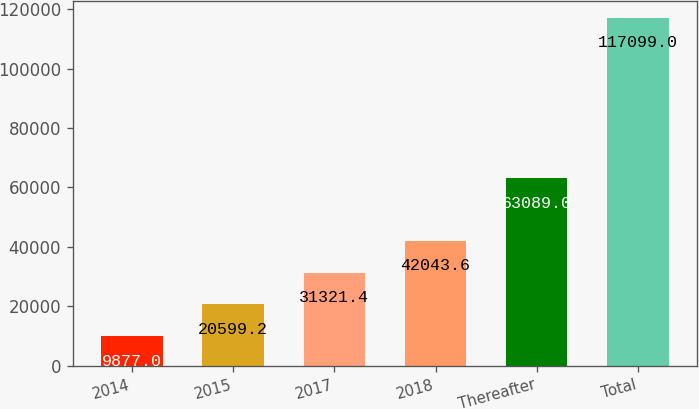Convert chart. <chart><loc_0><loc_0><loc_500><loc_500><bar_chart><fcel>2014<fcel>2015<fcel>2017<fcel>2018<fcel>Thereafter<fcel>Total<nl><fcel>9877<fcel>20599.2<fcel>31321.4<fcel>42043.6<fcel>63089<fcel>117099<nl></chart> 